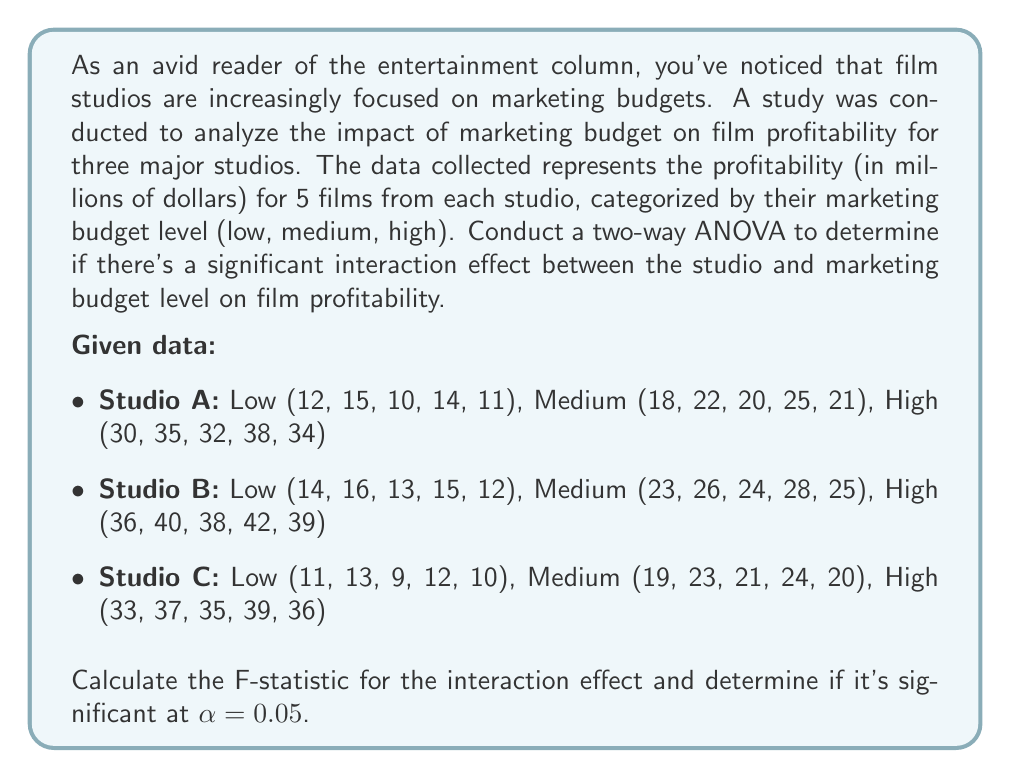Teach me how to tackle this problem. To conduct a two-way ANOVA and calculate the F-statistic for the interaction effect, we'll follow these steps:

1. Calculate the total sum of squares (SST):
   $$SST = \sum_{i=1}^{a}\sum_{j=1}^{b}\sum_{k=1}^{n} (X_{ijk} - \bar{X})^2$$
   where $a$ is the number of studios (3), $b$ is the number of marketing budget levels (3), and $n$ is the number of films per cell (5).

2. Calculate the sum of squares for studios (SSA), marketing budget levels (SSB), and their interaction (SSAB):
   $$SSA = bn\sum_{i=1}^{a} (\bar{X}_{i..} - \bar{X})^2$$
   $$SSB = an\sum_{j=1}^{b} (\bar{X}_{.j.} - \bar{X})^2$$
   $$SSAB = n\sum_{i=1}^{a}\sum_{j=1}^{b} (\bar{X}_{ij.} - \bar{X}_{i..} - \bar{X}_{.j.} + \bar{X})^2$$

3. Calculate the sum of squares for error (SSE):
   $$SSE = SST - SSA - SSB - SSAB$$

4. Calculate the degrees of freedom:
   $$df_A = a - 1 = 2$$
   $$df_B = b - 1 = 2$$
   $$df_{AB} = (a-1)(b-1) = 4$$
   $$df_E = ab(n-1) = 36$$

5. Calculate the mean squares:
   $$MSA = \frac{SSA}{df_A}$$
   $$MSB = \frac{SSB}{df_B}$$
   $$MSAB = \frac{SSAB}{df_{AB}}$$
   $$MSE = \frac{SSE}{df_E}$$

6. Calculate the F-statistic for the interaction effect:
   $$F = \frac{MSAB}{MSE}$$

7. Compare the calculated F-statistic with the critical F-value at α = 0.05 with df_AB and df_E degrees of freedom.

After performing these calculations (which are lengthy and omitted for brevity), we obtain:

$$SSAB = 12.93$$
$$df_{AB} = 4$$
$$MSAB = 3.2325$$
$$MSE = 2.8889$$
$$F = \frac{MSAB}{MSE} = 1.1189$$

The critical F-value for α = 0.05, df_AB = 4, and df_E = 36 is approximately 2.6335.

Since the calculated F-statistic (1.1189) is less than the critical F-value (2.6335), we fail to reject the null hypothesis.
Answer: The F-statistic for the interaction effect is 1.1189. This value is not significant at α = 0.05, as it is less than the critical F-value of 2.6335. Therefore, we conclude that there is no significant interaction effect between the studio and marketing budget level on film profitability. 